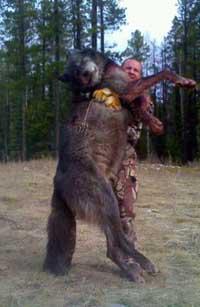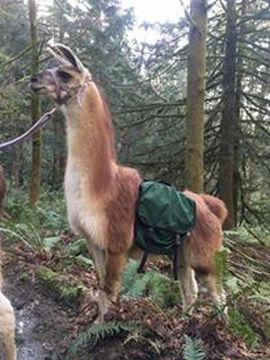The first image is the image on the left, the second image is the image on the right. Considering the images on both sides, is "In at least one image there is a hunter with deer horns and  two llames." valid? Answer yes or no. No. 